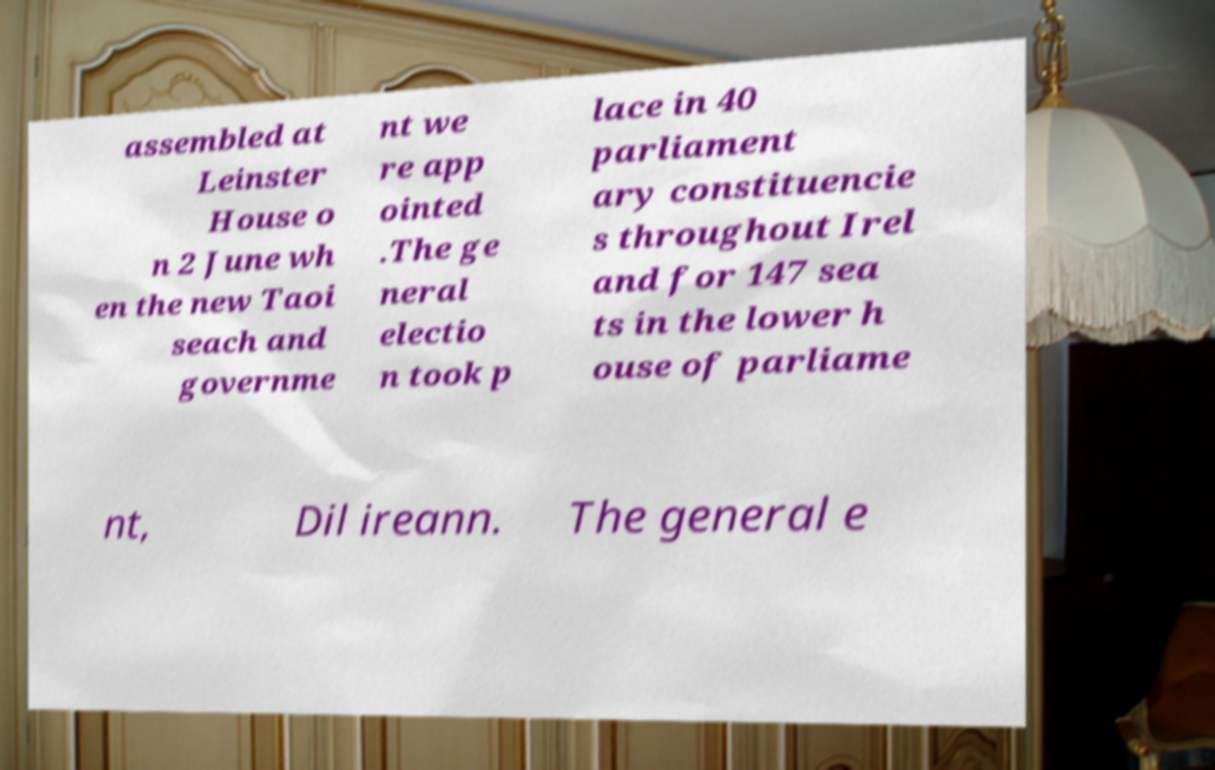Please identify and transcribe the text found in this image. assembled at Leinster House o n 2 June wh en the new Taoi seach and governme nt we re app ointed .The ge neral electio n took p lace in 40 parliament ary constituencie s throughout Irel and for 147 sea ts in the lower h ouse of parliame nt, Dil ireann. The general e 